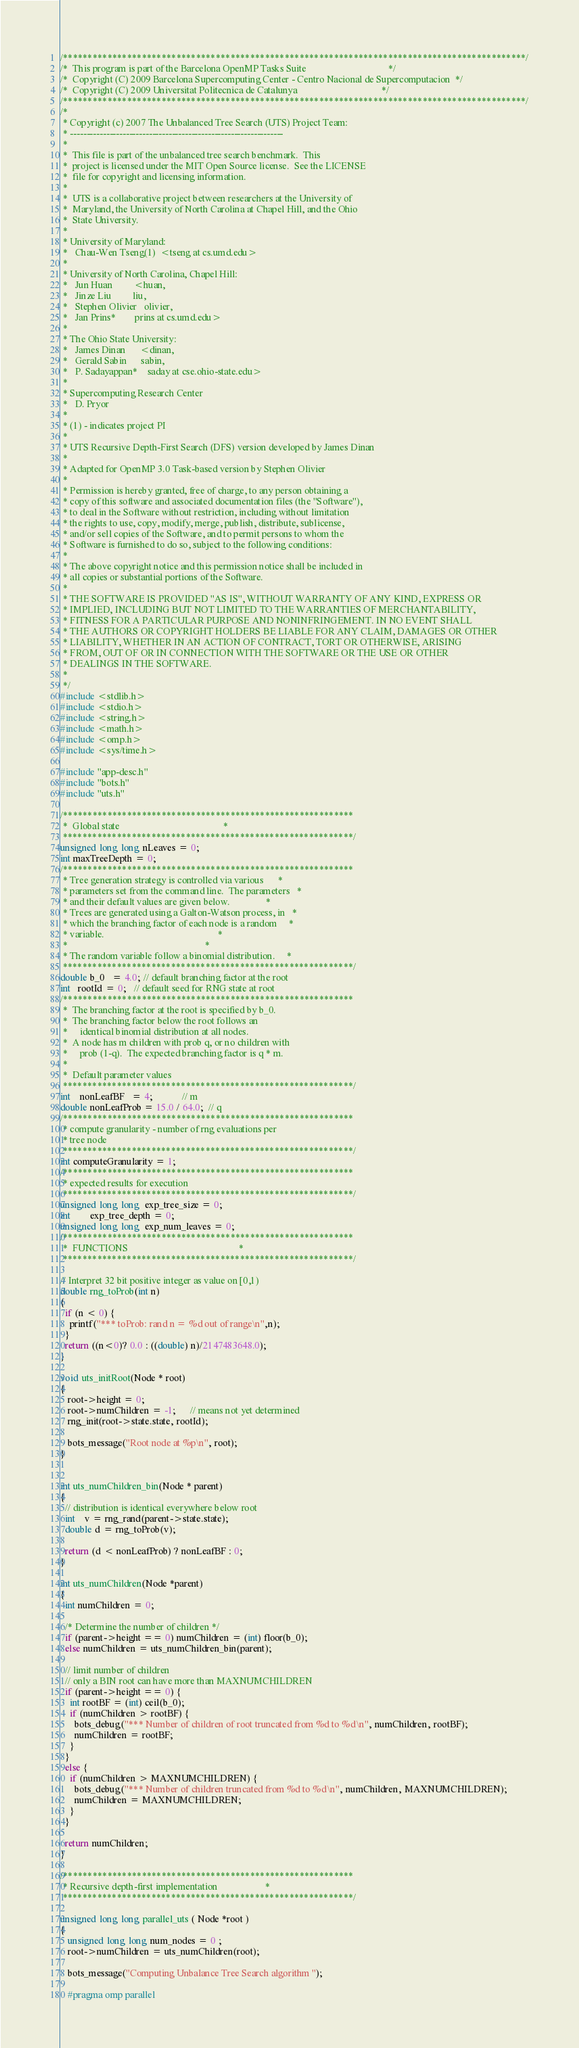Convert code to text. <code><loc_0><loc_0><loc_500><loc_500><_C_>/**********************************************************************************************/
/*  This program is part of the Barcelona OpenMP Tasks Suite                                  */
/*  Copyright (C) 2009 Barcelona Supercomputing Center - Centro Nacional de Supercomputacion  */
/*  Copyright (C) 2009 Universitat Politecnica de Catalunya                                   */
/**********************************************************************************************/
/*
 * Copyright (c) 2007 The Unbalanced Tree Search (UTS) Project Team:
 * -----------------------------------------------------------------
 *  
 *  This file is part of the unbalanced tree search benchmark.  This
 *  project is licensed under the MIT Open Source license.  See the LICENSE
 *  file for copyright and licensing information.
 *
 *  UTS is a collaborative project between researchers at the University of
 *  Maryland, the University of North Carolina at Chapel Hill, and the Ohio
 *  State University.
 *
 * University of Maryland:
 *   Chau-Wen Tseng(1)  <tseng at cs.umd.edu>
 *
 * University of North Carolina, Chapel Hill:
 *   Jun Huan         <huan,
 *   Jinze Liu         liu,
 *   Stephen Olivier   olivier,
 *   Jan Prins*        prins at cs.umd.edu>
 * 
 * The Ohio State University:
 *   James Dinan      <dinan,
 *   Gerald Sabin      sabin,
 *   P. Sadayappan*    saday at cse.ohio-state.edu>
 *
 * Supercomputing Research Center
 *   D. Pryor
 *
 * (1) - indicates project PI
 *
 * UTS Recursive Depth-First Search (DFS) version developed by James Dinan
 *
 * Adapted for OpenMP 3.0 Task-based version by Stephen Olivier
 *
 * Permission is hereby granted, free of charge, to any person obtaining a
 * copy of this software and associated documentation files (the "Software"),
 * to deal in the Software without restriction, including without limitation
 * the rights to use, copy, modify, merge, publish, distribute, sublicense,
 * and/or sell copies of the Software, and to permit persons to whom the
 * Software is furnished to do so, subject to the following conditions:
 *
 * The above copyright notice and this permission notice shall be included in
 * all copies or substantial portions of the Software.
 * 
 * THE SOFTWARE IS PROVIDED "AS IS", WITHOUT WARRANTY OF ANY KIND, EXPRESS OR
 * IMPLIED, INCLUDING BUT NOT LIMITED TO THE WARRANTIES OF MERCHANTABILITY,
 * FITNESS FOR A PARTICULAR PURPOSE AND NONINFRINGEMENT. IN NO EVENT SHALL
 * THE AUTHORS OR COPYRIGHT HOLDERS BE LIABLE FOR ANY CLAIM, DAMAGES OR OTHER
 * LIABILITY, WHETHER IN AN ACTION OF CONTRACT, TORT OR OTHERWISE, ARISING
 * FROM, OUT OF OR IN CONNECTION WITH THE SOFTWARE OR THE USE OR OTHER
 * DEALINGS IN THE SOFTWARE.
 *
 */
#include <stdlib.h>
#include <stdio.h>
#include <string.h>
#include <math.h>
#include <omp.h>
#include <sys/time.h>

#include "app-desc.h"
#include "bots.h"
#include "uts.h"

/***********************************************************
 *  Global state                                           *
 ***********************************************************/
unsigned long long nLeaves = 0;
int maxTreeDepth = 0;
/***********************************************************
 * Tree generation strategy is controlled via various      *
 * parameters set from the command line.  The parameters   *
 * and their default values are given below.               *
 * Trees are generated using a Galton-Watson process, in   *
 * which the branching factor of each node is a random     *
 * variable.                                               *
 *                                                         *
 * The random variable follow a binomial distribution.     *
 ***********************************************************/
double b_0   = 4.0; // default branching factor at the root
int   rootId = 0;   // default seed for RNG state at root
/***********************************************************
 *  The branching factor at the root is specified by b_0.
 *  The branching factor below the root follows an 
 *     identical binomial distribution at all nodes.
 *  A node has m children with prob q, or no children with 
 *     prob (1-q).  The expected branching factor is q * m.
 *
 *  Default parameter values 
 ***********************************************************/
int    nonLeafBF   = 4;            // m
double nonLeafProb = 15.0 / 64.0;  // q
/***********************************************************
 * compute granularity - number of rng evaluations per
 * tree node
 ***********************************************************/
int computeGranularity = 1;
/***********************************************************
 * expected results for execution
 ***********************************************************/
unsigned long long  exp_tree_size = 0;
int        exp_tree_depth = 0;
unsigned long long  exp_num_leaves = 0;
/***********************************************************
 *  FUNCTIONS                                              *
 ***********************************************************/

// Interpret 32 bit positive integer as value on [0,1)
double rng_toProb(int n)
{
  if (n < 0) {
    printf("*** toProb: rand n = %d out of range\n",n);
  }
  return ((n<0)? 0.0 : ((double) n)/2147483648.0);
}

void uts_initRoot(Node * root)
{
   root->height = 0;
   root->numChildren = -1;      // means not yet determined
   rng_init(root->state.state, rootId);

   bots_message("Root node at %p\n", root);
}


int uts_numChildren_bin(Node * parent)
{
  // distribution is identical everywhere below root
  int    v = rng_rand(parent->state.state);	
  double d = rng_toProb(v);

  return (d < nonLeafProb) ? nonLeafBF : 0;
}

int uts_numChildren(Node *parent)
{
  int numChildren = 0;

  /* Determine the number of children */
  if (parent->height == 0) numChildren = (int) floor(b_0);
  else numChildren = uts_numChildren_bin(parent);
  
  // limit number of children
  // only a BIN root can have more than MAXNUMCHILDREN
  if (parent->height == 0) {
    int rootBF = (int) ceil(b_0);
    if (numChildren > rootBF) {
      bots_debug("*** Number of children of root truncated from %d to %d\n", numChildren, rootBF);
      numChildren = rootBF;
    }
  }
  else {
    if (numChildren > MAXNUMCHILDREN) {
      bots_debug("*** Number of children truncated from %d to %d\n", numChildren, MAXNUMCHILDREN);
      numChildren = MAXNUMCHILDREN;
    }
  }

  return numChildren;
}

/***********************************************************
 * Recursive depth-first implementation                    *
 ***********************************************************/

unsigned long long parallel_uts ( Node *root )
{
   unsigned long long num_nodes = 0 ;
   root->numChildren = uts_numChildren(root);

   bots_message("Computing Unbalance Tree Search algorithm ");

   #pragma omp parallel  </code> 